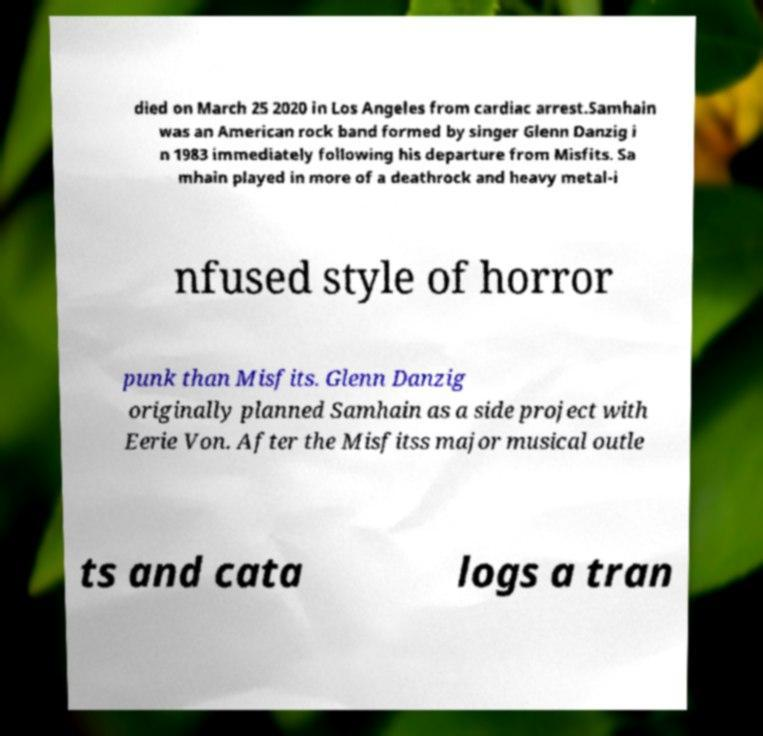I need the written content from this picture converted into text. Can you do that? died on March 25 2020 in Los Angeles from cardiac arrest.Samhain was an American rock band formed by singer Glenn Danzig i n 1983 immediately following his departure from Misfits. Sa mhain played in more of a deathrock and heavy metal-i nfused style of horror punk than Misfits. Glenn Danzig originally planned Samhain as a side project with Eerie Von. After the Misfitss major musical outle ts and cata logs a tran 